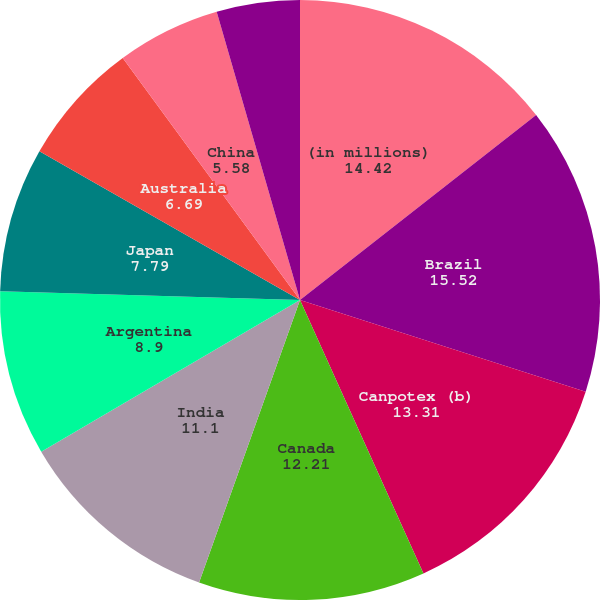Convert chart to OTSL. <chart><loc_0><loc_0><loc_500><loc_500><pie_chart><fcel>(in millions)<fcel>Brazil<fcel>Canpotex (b)<fcel>Canada<fcel>India<fcel>Argentina<fcel>Japan<fcel>Australia<fcel>China<fcel>Colombia<nl><fcel>14.42%<fcel>15.52%<fcel>13.31%<fcel>12.21%<fcel>11.1%<fcel>8.9%<fcel>7.79%<fcel>6.69%<fcel>5.58%<fcel>4.48%<nl></chart> 